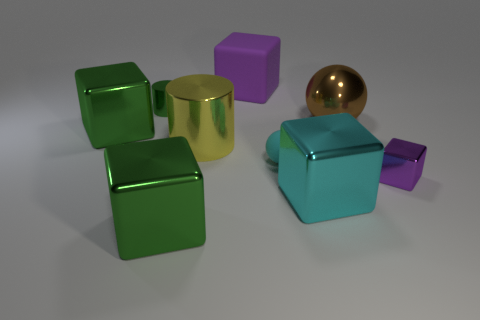Do the shiny block that is behind the small purple block and the tiny sphere have the same color?
Your answer should be compact. No. How many things are either large shiny spheres right of the cyan cube or green metallic things?
Ensure brevity in your answer.  4. Are there any large brown metal balls in front of the big cylinder?
Give a very brief answer. No. There is a object that is the same color as the small shiny cube; what material is it?
Your answer should be very brief. Rubber. Is the material of the tiny sphere that is on the left side of the cyan metallic block the same as the big purple cube?
Your response must be concise. Yes. Is there a big brown object in front of the large green cube that is behind the ball that is in front of the shiny sphere?
Make the answer very short. No. How many cubes are either tiny brown metallic objects or brown shiny things?
Your answer should be very brief. 0. What is the material of the green cube that is behind the purple metal thing?
Offer a terse response. Metal. What size is the metallic block that is the same color as the big rubber cube?
Offer a terse response. Small. Do the tiny metal object that is to the right of the green shiny cylinder and the small metallic object that is left of the purple metallic object have the same color?
Ensure brevity in your answer.  No. 